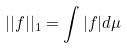Convert formula to latex. <formula><loc_0><loc_0><loc_500><loc_500>| | f | | _ { 1 } = \int | f | d \mu</formula> 